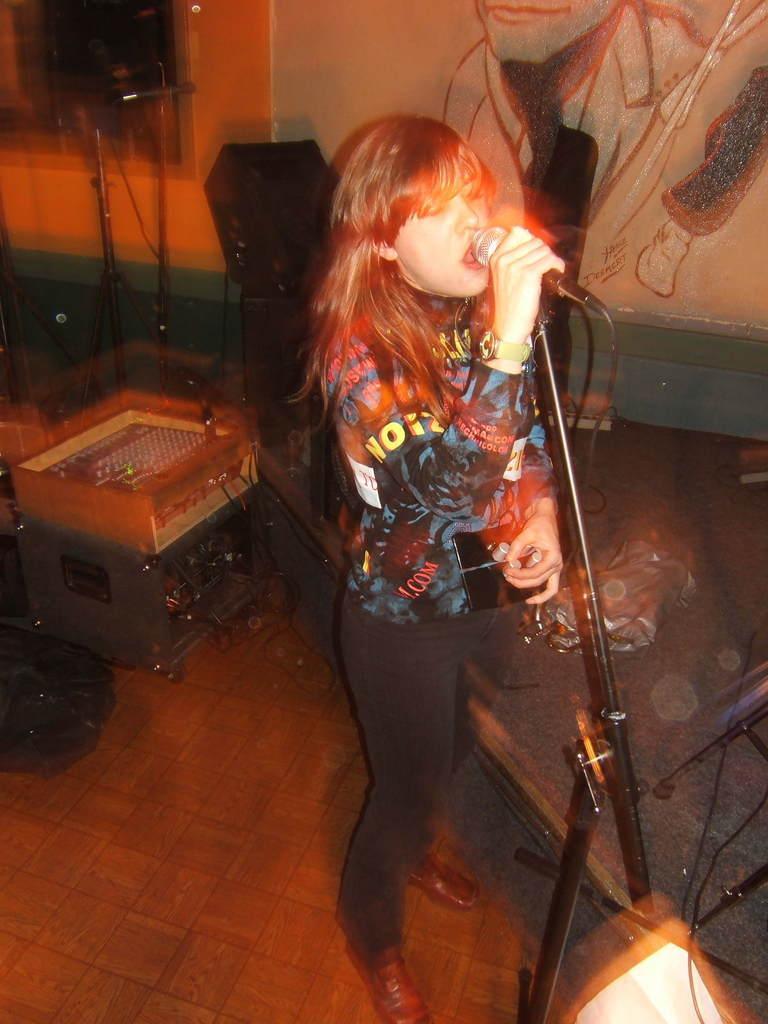In one or two sentences, can you explain what this image depicts? In this image I can see a women is standing in the front and I can see she is holding a mic. In the background I can see few equipment, two more mics and a painting on the wall. On the bottom right side of this image I can see a light and I can see this image is little bit blurry. 